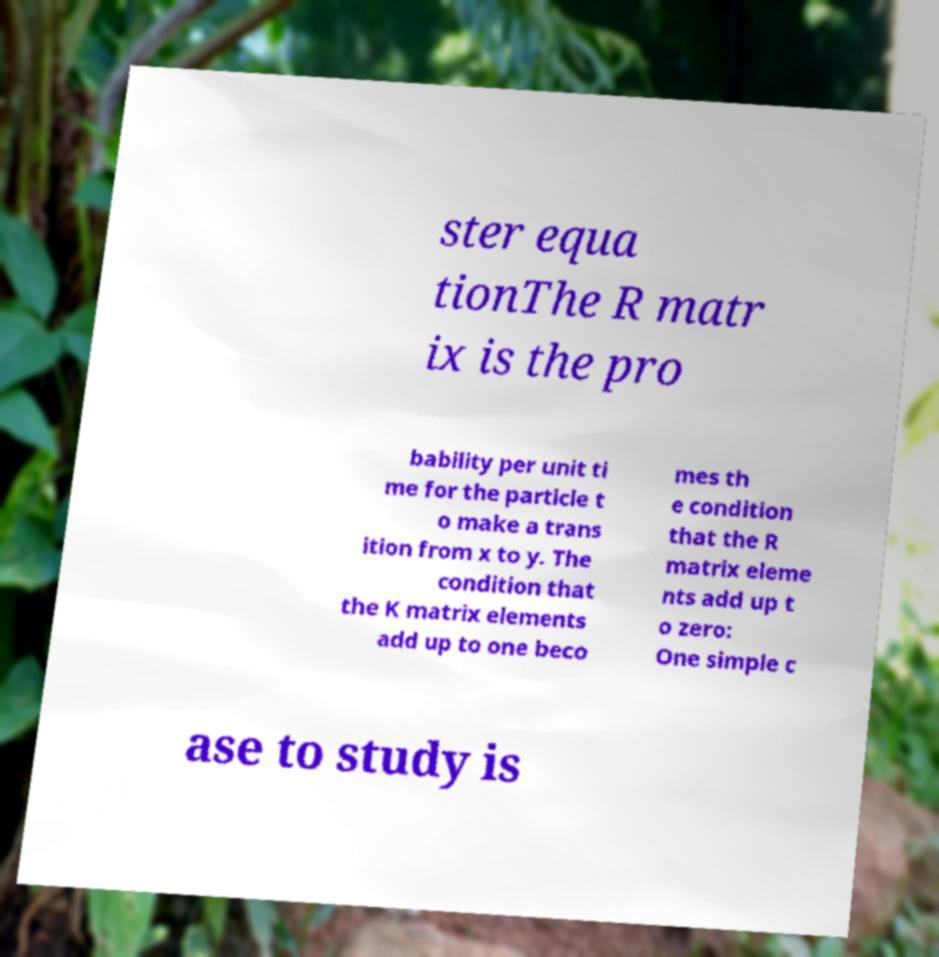Please read and relay the text visible in this image. What does it say? ster equa tionThe R matr ix is the pro bability per unit ti me for the particle t o make a trans ition from x to y. The condition that the K matrix elements add up to one beco mes th e condition that the R matrix eleme nts add up t o zero: One simple c ase to study is 